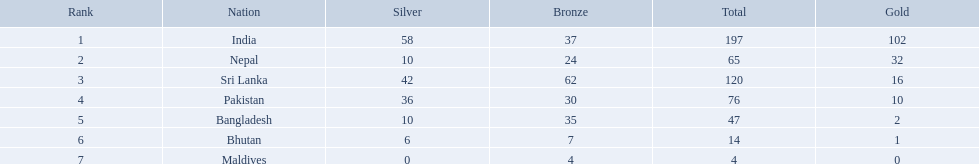Which countries won medals? India, Nepal, Sri Lanka, Pakistan, Bangladesh, Bhutan, Maldives. Parse the table in full. {'header': ['Rank', 'Nation', 'Silver', 'Bronze', 'Total', 'Gold'], 'rows': [['1', 'India', '58', '37', '197', '102'], ['2', 'Nepal', '10', '24', '65', '32'], ['3', 'Sri Lanka', '42', '62', '120', '16'], ['4', 'Pakistan', '36', '30', '76', '10'], ['5', 'Bangladesh', '10', '35', '47', '2'], ['6', 'Bhutan', '6', '7', '14', '1'], ['7', 'Maldives', '0', '4', '4', '0']]} Which won the most? India. Which won the fewest? Maldives. What countries attended the 1999 south asian games? India, Nepal, Sri Lanka, Pakistan, Bangladesh, Bhutan, Maldives. Which of these countries had 32 gold medals? Nepal. 